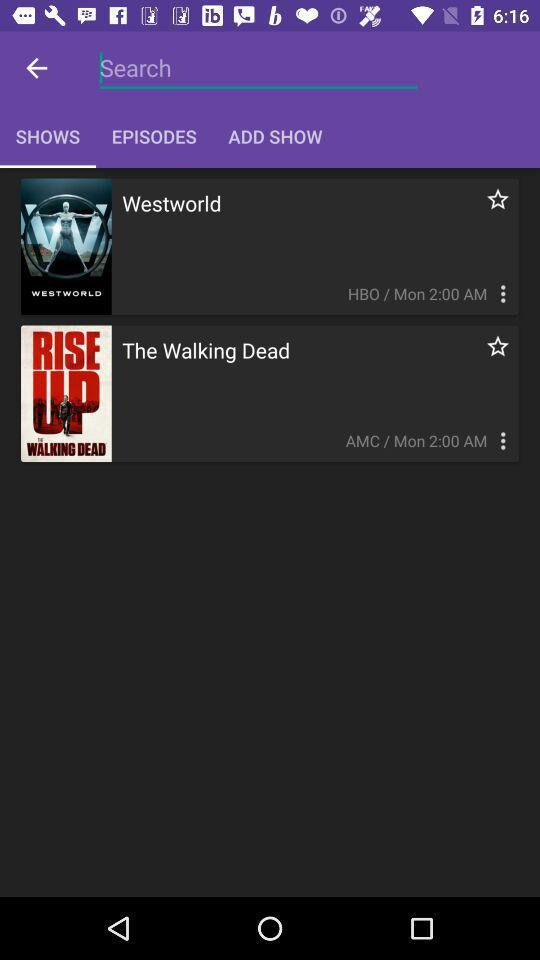What is the broadcast time of Westworld? The broadcast time of Westworld is 2:00 AM. 